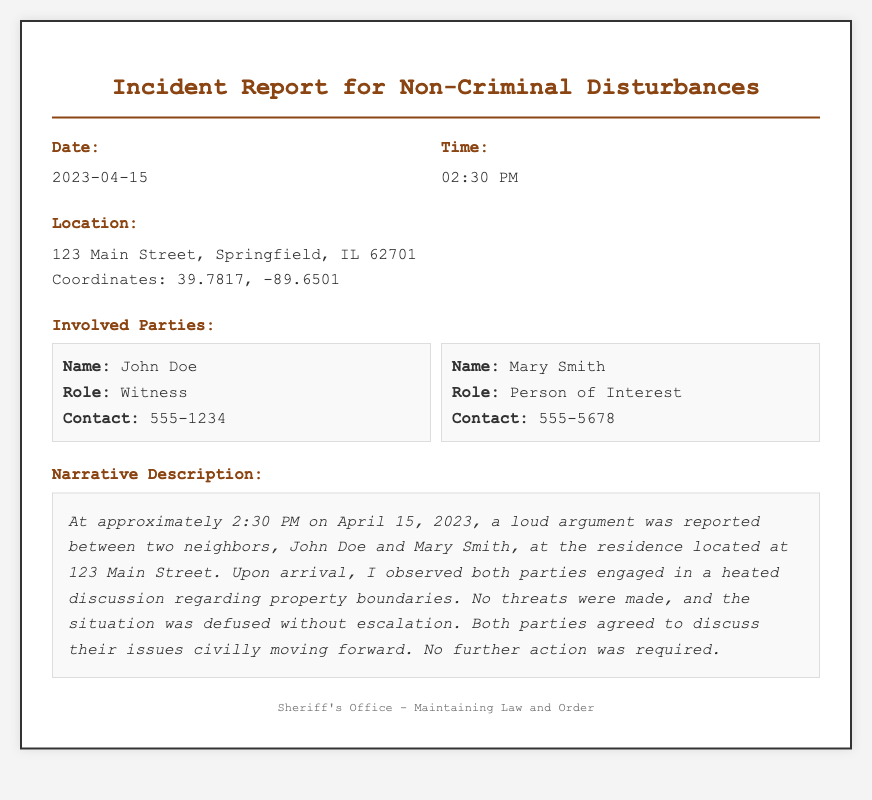What is the date of the incident? The date of the incident is listed under the "Date" section of the document, which reads 2023-04-15.
Answer: 2023-04-15 What time did the incident occur? The time of the incident is indicated in the "Time" section of the document, which states 02:30 PM.
Answer: 02:30 PM Where did the incident take place? The location of the incident can be found in the "Location" section, which specifies 123 Main Street, Springfield, IL 62701.
Answer: 123 Main Street, Springfield, IL 62701 Who was the witness involved in the incident? The "Involved Parties" section lists John Doe as a witness, which is provided under his details.
Answer: John Doe What was the primary issue leading to the disturbance? The narrative description outlines that the heated discussion was regarding property boundaries, summarizing the conflict.
Answer: Property boundaries What action was taken during the incident? The narrative indicates that no threats were made and the situation was defused without escalation, showing how it was handled.
Answer: Defused How many parties were involved in the incident? The "Involved Parties" section lists two people, John Doe and Mary Smith, indicating the count.
Answer: Two What is the role of Mary Smith in the incident? The details for Mary Smith in the "Involved Parties" section specify her role as "Person of Interest."
Answer: Person of Interest What is included in the footer of the document? The footer of the document states the Sheriff's Office and its dedication to maintaining law and order.
Answer: Sheriff's Office - Maintaining Law and Order 